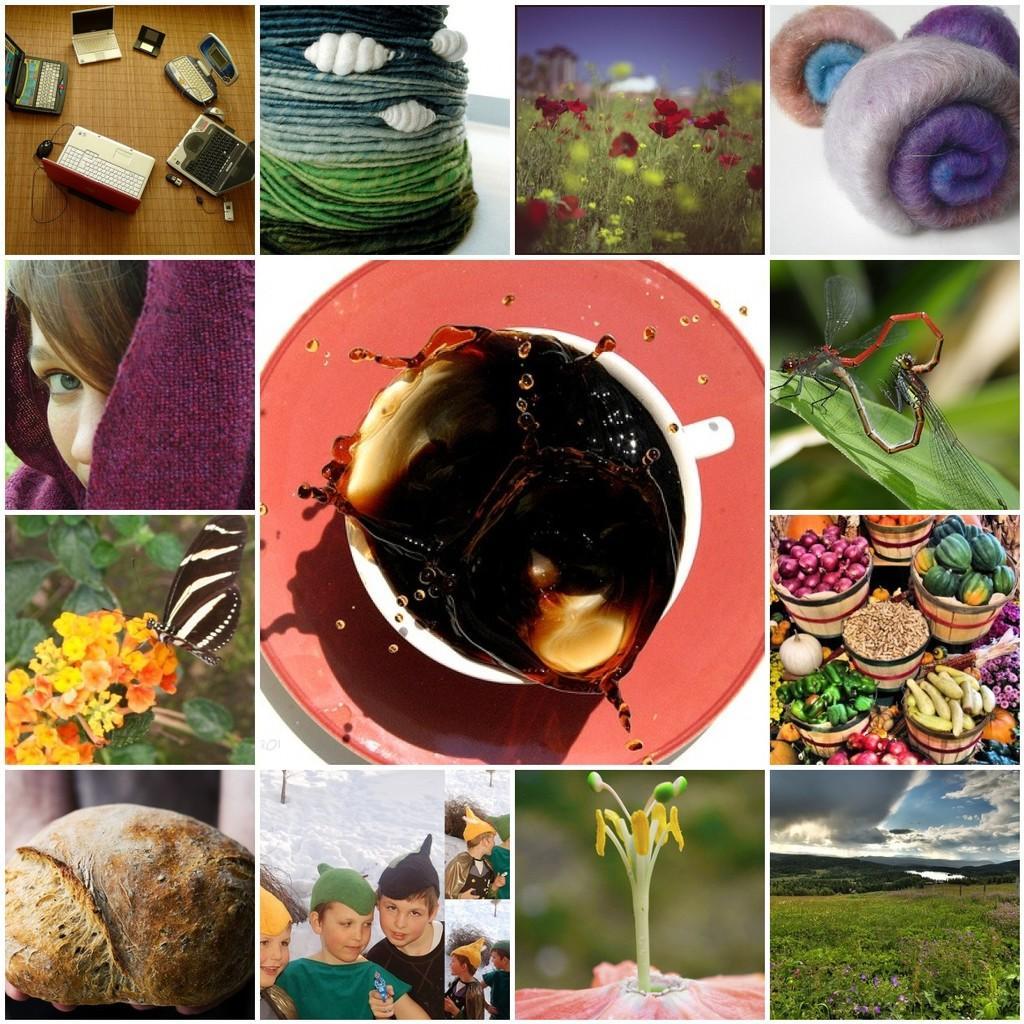Could you give a brief overview of what you see in this image? In this image we can see a collage image. At the top we can see the laptops, ropes, plants with flower and clothes. In the middle we can see the drink in a cup which is placed on a saucer. On the right side, we can see dragonflies on a leaf, a group of vegetables in the baskets, grass and the sky. At the bottom we can see the persons and a flower. On the left side, we can see a butterfly on the flowers and a person. 